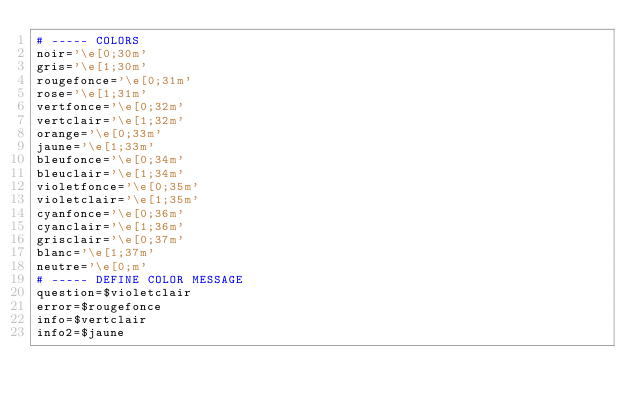Convert code to text. <code><loc_0><loc_0><loc_500><loc_500><_Bash_># ----- COLORS 
noir='\e[0;30m'
gris='\e[1;30m'
rougefonce='\e[0;31m' 
rose='\e[1;31m'
vertfonce='\e[0;32m'
vertclair='\e[1;32m'
orange='\e[0;33m'
jaune='\e[1;33m'
bleufonce='\e[0;34m'
bleuclair='\e[1;34m'
violetfonce='\e[0;35m'
violetclair='\e[1;35m'
cyanfonce='\e[0;36m'
cyanclair='\e[1;36m'
grisclair='\e[0;37m'
blanc='\e[1;37m'
neutre='\e[0;m'
# ----- DEFINE COLOR MESSAGE
question=$violetclair
error=$rougefonce
info=$vertclair
info2=$jaune

</code> 